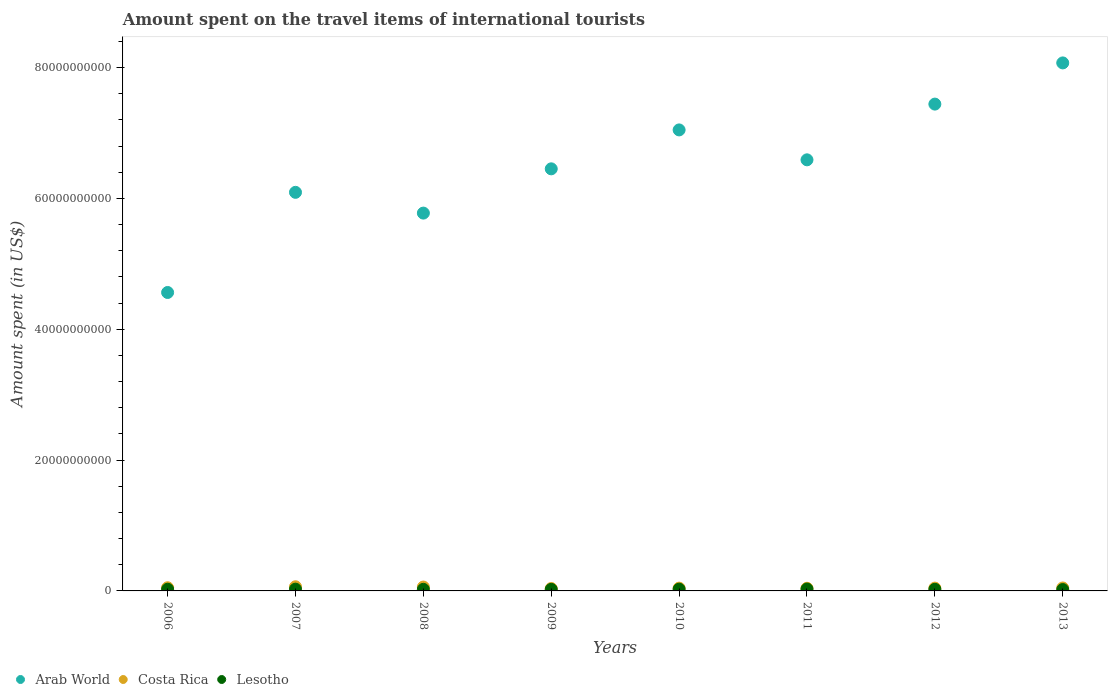Is the number of dotlines equal to the number of legend labels?
Your answer should be compact. Yes. What is the amount spent on the travel items of international tourists in Arab World in 2006?
Offer a very short reply. 4.56e+1. Across all years, what is the maximum amount spent on the travel items of international tourists in Costa Rica?
Provide a short and direct response. 6.34e+08. Across all years, what is the minimum amount spent on the travel items of international tourists in Costa Rica?
Keep it short and to the point. 3.67e+08. In which year was the amount spent on the travel items of international tourists in Lesotho minimum?
Ensure brevity in your answer.  2013. What is the total amount spent on the travel items of international tourists in Costa Rica in the graph?
Provide a short and direct response. 3.79e+09. What is the difference between the amount spent on the travel items of international tourists in Costa Rica in 2006 and that in 2011?
Provide a short and direct response. 8.00e+07. What is the difference between the amount spent on the travel items of international tourists in Arab World in 2009 and the amount spent on the travel items of international tourists in Lesotho in 2010?
Offer a terse response. 6.42e+1. What is the average amount spent on the travel items of international tourists in Lesotho per year?
Offer a very short reply. 2.54e+08. In the year 2007, what is the difference between the amount spent on the travel items of international tourists in Lesotho and amount spent on the travel items of international tourists in Costa Rica?
Offer a very short reply. -3.66e+08. What is the ratio of the amount spent on the travel items of international tourists in Lesotho in 2008 to that in 2009?
Provide a short and direct response. 1.02. Is the amount spent on the travel items of international tourists in Lesotho in 2009 less than that in 2011?
Make the answer very short. Yes. What is the difference between the highest and the second highest amount spent on the travel items of international tourists in Costa Rica?
Provide a succinct answer. 4.10e+07. What is the difference between the highest and the lowest amount spent on the travel items of international tourists in Arab World?
Offer a terse response. 3.51e+1. Is the sum of the amount spent on the travel items of international tourists in Lesotho in 2011 and 2012 greater than the maximum amount spent on the travel items of international tourists in Costa Rica across all years?
Your answer should be compact. No. Is it the case that in every year, the sum of the amount spent on the travel items of international tourists in Arab World and amount spent on the travel items of international tourists in Costa Rica  is greater than the amount spent on the travel items of international tourists in Lesotho?
Provide a succinct answer. Yes. Does the amount spent on the travel items of international tourists in Lesotho monotonically increase over the years?
Your response must be concise. No. How many legend labels are there?
Your response must be concise. 3. How are the legend labels stacked?
Provide a short and direct response. Horizontal. What is the title of the graph?
Provide a short and direct response. Amount spent on the travel items of international tourists. Does "Turkey" appear as one of the legend labels in the graph?
Provide a short and direct response. No. What is the label or title of the Y-axis?
Provide a short and direct response. Amount spent (in US$). What is the Amount spent (in US$) in Arab World in 2006?
Your answer should be compact. 4.56e+1. What is the Amount spent (in US$) of Costa Rica in 2006?
Your answer should be very brief. 4.85e+08. What is the Amount spent (in US$) in Lesotho in 2006?
Your response must be concise. 2.60e+08. What is the Amount spent (in US$) in Arab World in 2007?
Make the answer very short. 6.09e+1. What is the Amount spent (in US$) in Costa Rica in 2007?
Offer a terse response. 6.34e+08. What is the Amount spent (in US$) in Lesotho in 2007?
Offer a terse response. 2.68e+08. What is the Amount spent (in US$) of Arab World in 2008?
Your answer should be compact. 5.78e+1. What is the Amount spent (in US$) of Costa Rica in 2008?
Your response must be concise. 5.93e+08. What is the Amount spent (in US$) of Lesotho in 2008?
Offer a terse response. 2.43e+08. What is the Amount spent (in US$) of Arab World in 2009?
Make the answer very short. 6.45e+1. What is the Amount spent (in US$) of Costa Rica in 2009?
Offer a terse response. 3.67e+08. What is the Amount spent (in US$) of Lesotho in 2009?
Provide a short and direct response. 2.39e+08. What is the Amount spent (in US$) in Arab World in 2010?
Keep it short and to the point. 7.05e+1. What is the Amount spent (in US$) of Costa Rica in 2010?
Offer a very short reply. 4.24e+08. What is the Amount spent (in US$) in Lesotho in 2010?
Provide a succinct answer. 2.70e+08. What is the Amount spent (in US$) of Arab World in 2011?
Make the answer very short. 6.59e+1. What is the Amount spent (in US$) of Costa Rica in 2011?
Ensure brevity in your answer.  4.05e+08. What is the Amount spent (in US$) of Lesotho in 2011?
Keep it short and to the point. 2.90e+08. What is the Amount spent (in US$) in Arab World in 2012?
Keep it short and to the point. 7.44e+1. What is the Amount spent (in US$) in Costa Rica in 2012?
Keep it short and to the point. 4.29e+08. What is the Amount spent (in US$) in Lesotho in 2012?
Provide a short and direct response. 2.48e+08. What is the Amount spent (in US$) in Arab World in 2013?
Give a very brief answer. 8.07e+1. What is the Amount spent (in US$) of Costa Rica in 2013?
Your response must be concise. 4.50e+08. What is the Amount spent (in US$) in Lesotho in 2013?
Offer a terse response. 2.10e+08. Across all years, what is the maximum Amount spent (in US$) of Arab World?
Your response must be concise. 8.07e+1. Across all years, what is the maximum Amount spent (in US$) of Costa Rica?
Provide a succinct answer. 6.34e+08. Across all years, what is the maximum Amount spent (in US$) of Lesotho?
Your answer should be very brief. 2.90e+08. Across all years, what is the minimum Amount spent (in US$) of Arab World?
Make the answer very short. 4.56e+1. Across all years, what is the minimum Amount spent (in US$) in Costa Rica?
Offer a very short reply. 3.67e+08. Across all years, what is the minimum Amount spent (in US$) in Lesotho?
Offer a terse response. 2.10e+08. What is the total Amount spent (in US$) in Arab World in the graph?
Your answer should be compact. 5.20e+11. What is the total Amount spent (in US$) in Costa Rica in the graph?
Keep it short and to the point. 3.79e+09. What is the total Amount spent (in US$) of Lesotho in the graph?
Provide a succinct answer. 2.03e+09. What is the difference between the Amount spent (in US$) of Arab World in 2006 and that in 2007?
Provide a short and direct response. -1.53e+1. What is the difference between the Amount spent (in US$) in Costa Rica in 2006 and that in 2007?
Your response must be concise. -1.49e+08. What is the difference between the Amount spent (in US$) in Lesotho in 2006 and that in 2007?
Make the answer very short. -8.00e+06. What is the difference between the Amount spent (in US$) of Arab World in 2006 and that in 2008?
Provide a short and direct response. -1.21e+1. What is the difference between the Amount spent (in US$) of Costa Rica in 2006 and that in 2008?
Provide a short and direct response. -1.08e+08. What is the difference between the Amount spent (in US$) of Lesotho in 2006 and that in 2008?
Offer a terse response. 1.70e+07. What is the difference between the Amount spent (in US$) of Arab World in 2006 and that in 2009?
Your answer should be very brief. -1.89e+1. What is the difference between the Amount spent (in US$) of Costa Rica in 2006 and that in 2009?
Ensure brevity in your answer.  1.18e+08. What is the difference between the Amount spent (in US$) in Lesotho in 2006 and that in 2009?
Your answer should be compact. 2.10e+07. What is the difference between the Amount spent (in US$) of Arab World in 2006 and that in 2010?
Your response must be concise. -2.48e+1. What is the difference between the Amount spent (in US$) of Costa Rica in 2006 and that in 2010?
Provide a succinct answer. 6.10e+07. What is the difference between the Amount spent (in US$) in Lesotho in 2006 and that in 2010?
Ensure brevity in your answer.  -1.00e+07. What is the difference between the Amount spent (in US$) in Arab World in 2006 and that in 2011?
Keep it short and to the point. -2.03e+1. What is the difference between the Amount spent (in US$) of Costa Rica in 2006 and that in 2011?
Your response must be concise. 8.00e+07. What is the difference between the Amount spent (in US$) of Lesotho in 2006 and that in 2011?
Offer a very short reply. -3.00e+07. What is the difference between the Amount spent (in US$) in Arab World in 2006 and that in 2012?
Give a very brief answer. -2.88e+1. What is the difference between the Amount spent (in US$) in Costa Rica in 2006 and that in 2012?
Make the answer very short. 5.60e+07. What is the difference between the Amount spent (in US$) of Lesotho in 2006 and that in 2012?
Your answer should be compact. 1.20e+07. What is the difference between the Amount spent (in US$) in Arab World in 2006 and that in 2013?
Your response must be concise. -3.51e+1. What is the difference between the Amount spent (in US$) of Costa Rica in 2006 and that in 2013?
Your response must be concise. 3.50e+07. What is the difference between the Amount spent (in US$) of Arab World in 2007 and that in 2008?
Your answer should be very brief. 3.17e+09. What is the difference between the Amount spent (in US$) in Costa Rica in 2007 and that in 2008?
Provide a succinct answer. 4.10e+07. What is the difference between the Amount spent (in US$) of Lesotho in 2007 and that in 2008?
Your response must be concise. 2.50e+07. What is the difference between the Amount spent (in US$) of Arab World in 2007 and that in 2009?
Your answer should be very brief. -3.59e+09. What is the difference between the Amount spent (in US$) in Costa Rica in 2007 and that in 2009?
Your answer should be compact. 2.67e+08. What is the difference between the Amount spent (in US$) in Lesotho in 2007 and that in 2009?
Provide a short and direct response. 2.90e+07. What is the difference between the Amount spent (in US$) in Arab World in 2007 and that in 2010?
Provide a succinct answer. -9.54e+09. What is the difference between the Amount spent (in US$) in Costa Rica in 2007 and that in 2010?
Your answer should be compact. 2.10e+08. What is the difference between the Amount spent (in US$) in Arab World in 2007 and that in 2011?
Your response must be concise. -4.97e+09. What is the difference between the Amount spent (in US$) in Costa Rica in 2007 and that in 2011?
Keep it short and to the point. 2.29e+08. What is the difference between the Amount spent (in US$) of Lesotho in 2007 and that in 2011?
Give a very brief answer. -2.20e+07. What is the difference between the Amount spent (in US$) in Arab World in 2007 and that in 2012?
Your answer should be very brief. -1.35e+1. What is the difference between the Amount spent (in US$) in Costa Rica in 2007 and that in 2012?
Offer a very short reply. 2.05e+08. What is the difference between the Amount spent (in US$) of Lesotho in 2007 and that in 2012?
Offer a very short reply. 2.00e+07. What is the difference between the Amount spent (in US$) of Arab World in 2007 and that in 2013?
Provide a short and direct response. -1.98e+1. What is the difference between the Amount spent (in US$) in Costa Rica in 2007 and that in 2013?
Ensure brevity in your answer.  1.84e+08. What is the difference between the Amount spent (in US$) in Lesotho in 2007 and that in 2013?
Provide a succinct answer. 5.80e+07. What is the difference between the Amount spent (in US$) in Arab World in 2008 and that in 2009?
Make the answer very short. -6.77e+09. What is the difference between the Amount spent (in US$) of Costa Rica in 2008 and that in 2009?
Your response must be concise. 2.26e+08. What is the difference between the Amount spent (in US$) in Lesotho in 2008 and that in 2009?
Make the answer very short. 4.00e+06. What is the difference between the Amount spent (in US$) in Arab World in 2008 and that in 2010?
Your answer should be compact. -1.27e+1. What is the difference between the Amount spent (in US$) in Costa Rica in 2008 and that in 2010?
Provide a short and direct response. 1.69e+08. What is the difference between the Amount spent (in US$) in Lesotho in 2008 and that in 2010?
Your response must be concise. -2.70e+07. What is the difference between the Amount spent (in US$) of Arab World in 2008 and that in 2011?
Keep it short and to the point. -8.14e+09. What is the difference between the Amount spent (in US$) of Costa Rica in 2008 and that in 2011?
Make the answer very short. 1.88e+08. What is the difference between the Amount spent (in US$) in Lesotho in 2008 and that in 2011?
Provide a succinct answer. -4.70e+07. What is the difference between the Amount spent (in US$) in Arab World in 2008 and that in 2012?
Provide a short and direct response. -1.67e+1. What is the difference between the Amount spent (in US$) of Costa Rica in 2008 and that in 2012?
Offer a very short reply. 1.64e+08. What is the difference between the Amount spent (in US$) of Lesotho in 2008 and that in 2012?
Your response must be concise. -5.00e+06. What is the difference between the Amount spent (in US$) of Arab World in 2008 and that in 2013?
Offer a very short reply. -2.30e+1. What is the difference between the Amount spent (in US$) in Costa Rica in 2008 and that in 2013?
Give a very brief answer. 1.43e+08. What is the difference between the Amount spent (in US$) of Lesotho in 2008 and that in 2013?
Provide a short and direct response. 3.30e+07. What is the difference between the Amount spent (in US$) in Arab World in 2009 and that in 2010?
Offer a terse response. -5.95e+09. What is the difference between the Amount spent (in US$) of Costa Rica in 2009 and that in 2010?
Provide a short and direct response. -5.70e+07. What is the difference between the Amount spent (in US$) in Lesotho in 2009 and that in 2010?
Provide a succinct answer. -3.10e+07. What is the difference between the Amount spent (in US$) in Arab World in 2009 and that in 2011?
Provide a short and direct response. -1.38e+09. What is the difference between the Amount spent (in US$) of Costa Rica in 2009 and that in 2011?
Make the answer very short. -3.80e+07. What is the difference between the Amount spent (in US$) of Lesotho in 2009 and that in 2011?
Ensure brevity in your answer.  -5.10e+07. What is the difference between the Amount spent (in US$) in Arab World in 2009 and that in 2012?
Make the answer very short. -9.90e+09. What is the difference between the Amount spent (in US$) of Costa Rica in 2009 and that in 2012?
Keep it short and to the point. -6.20e+07. What is the difference between the Amount spent (in US$) in Lesotho in 2009 and that in 2012?
Your response must be concise. -9.00e+06. What is the difference between the Amount spent (in US$) of Arab World in 2009 and that in 2013?
Keep it short and to the point. -1.62e+1. What is the difference between the Amount spent (in US$) in Costa Rica in 2009 and that in 2013?
Your answer should be compact. -8.30e+07. What is the difference between the Amount spent (in US$) of Lesotho in 2009 and that in 2013?
Offer a terse response. 2.90e+07. What is the difference between the Amount spent (in US$) of Arab World in 2010 and that in 2011?
Make the answer very short. 4.57e+09. What is the difference between the Amount spent (in US$) of Costa Rica in 2010 and that in 2011?
Ensure brevity in your answer.  1.90e+07. What is the difference between the Amount spent (in US$) in Lesotho in 2010 and that in 2011?
Provide a succinct answer. -2.00e+07. What is the difference between the Amount spent (in US$) of Arab World in 2010 and that in 2012?
Your response must be concise. -3.95e+09. What is the difference between the Amount spent (in US$) of Costa Rica in 2010 and that in 2012?
Your response must be concise. -5.00e+06. What is the difference between the Amount spent (in US$) in Lesotho in 2010 and that in 2012?
Provide a succinct answer. 2.20e+07. What is the difference between the Amount spent (in US$) in Arab World in 2010 and that in 2013?
Provide a short and direct response. -1.02e+1. What is the difference between the Amount spent (in US$) of Costa Rica in 2010 and that in 2013?
Give a very brief answer. -2.60e+07. What is the difference between the Amount spent (in US$) in Lesotho in 2010 and that in 2013?
Offer a terse response. 6.00e+07. What is the difference between the Amount spent (in US$) of Arab World in 2011 and that in 2012?
Give a very brief answer. -8.52e+09. What is the difference between the Amount spent (in US$) in Costa Rica in 2011 and that in 2012?
Your response must be concise. -2.40e+07. What is the difference between the Amount spent (in US$) in Lesotho in 2011 and that in 2012?
Offer a very short reply. 4.20e+07. What is the difference between the Amount spent (in US$) in Arab World in 2011 and that in 2013?
Your answer should be compact. -1.48e+1. What is the difference between the Amount spent (in US$) of Costa Rica in 2011 and that in 2013?
Provide a short and direct response. -4.50e+07. What is the difference between the Amount spent (in US$) of Lesotho in 2011 and that in 2013?
Make the answer very short. 8.00e+07. What is the difference between the Amount spent (in US$) of Arab World in 2012 and that in 2013?
Offer a terse response. -6.30e+09. What is the difference between the Amount spent (in US$) in Costa Rica in 2012 and that in 2013?
Give a very brief answer. -2.10e+07. What is the difference between the Amount spent (in US$) of Lesotho in 2012 and that in 2013?
Your response must be concise. 3.80e+07. What is the difference between the Amount spent (in US$) of Arab World in 2006 and the Amount spent (in US$) of Costa Rica in 2007?
Ensure brevity in your answer.  4.50e+1. What is the difference between the Amount spent (in US$) in Arab World in 2006 and the Amount spent (in US$) in Lesotho in 2007?
Give a very brief answer. 4.54e+1. What is the difference between the Amount spent (in US$) in Costa Rica in 2006 and the Amount spent (in US$) in Lesotho in 2007?
Offer a very short reply. 2.17e+08. What is the difference between the Amount spent (in US$) of Arab World in 2006 and the Amount spent (in US$) of Costa Rica in 2008?
Provide a succinct answer. 4.50e+1. What is the difference between the Amount spent (in US$) in Arab World in 2006 and the Amount spent (in US$) in Lesotho in 2008?
Your answer should be very brief. 4.54e+1. What is the difference between the Amount spent (in US$) of Costa Rica in 2006 and the Amount spent (in US$) of Lesotho in 2008?
Keep it short and to the point. 2.42e+08. What is the difference between the Amount spent (in US$) in Arab World in 2006 and the Amount spent (in US$) in Costa Rica in 2009?
Provide a short and direct response. 4.53e+1. What is the difference between the Amount spent (in US$) of Arab World in 2006 and the Amount spent (in US$) of Lesotho in 2009?
Ensure brevity in your answer.  4.54e+1. What is the difference between the Amount spent (in US$) of Costa Rica in 2006 and the Amount spent (in US$) of Lesotho in 2009?
Provide a succinct answer. 2.46e+08. What is the difference between the Amount spent (in US$) in Arab World in 2006 and the Amount spent (in US$) in Costa Rica in 2010?
Your answer should be compact. 4.52e+1. What is the difference between the Amount spent (in US$) in Arab World in 2006 and the Amount spent (in US$) in Lesotho in 2010?
Your response must be concise. 4.53e+1. What is the difference between the Amount spent (in US$) in Costa Rica in 2006 and the Amount spent (in US$) in Lesotho in 2010?
Ensure brevity in your answer.  2.15e+08. What is the difference between the Amount spent (in US$) of Arab World in 2006 and the Amount spent (in US$) of Costa Rica in 2011?
Offer a terse response. 4.52e+1. What is the difference between the Amount spent (in US$) of Arab World in 2006 and the Amount spent (in US$) of Lesotho in 2011?
Keep it short and to the point. 4.53e+1. What is the difference between the Amount spent (in US$) of Costa Rica in 2006 and the Amount spent (in US$) of Lesotho in 2011?
Offer a terse response. 1.95e+08. What is the difference between the Amount spent (in US$) in Arab World in 2006 and the Amount spent (in US$) in Costa Rica in 2012?
Keep it short and to the point. 4.52e+1. What is the difference between the Amount spent (in US$) in Arab World in 2006 and the Amount spent (in US$) in Lesotho in 2012?
Keep it short and to the point. 4.54e+1. What is the difference between the Amount spent (in US$) of Costa Rica in 2006 and the Amount spent (in US$) of Lesotho in 2012?
Provide a short and direct response. 2.37e+08. What is the difference between the Amount spent (in US$) of Arab World in 2006 and the Amount spent (in US$) of Costa Rica in 2013?
Make the answer very short. 4.52e+1. What is the difference between the Amount spent (in US$) of Arab World in 2006 and the Amount spent (in US$) of Lesotho in 2013?
Make the answer very short. 4.54e+1. What is the difference between the Amount spent (in US$) of Costa Rica in 2006 and the Amount spent (in US$) of Lesotho in 2013?
Provide a succinct answer. 2.75e+08. What is the difference between the Amount spent (in US$) in Arab World in 2007 and the Amount spent (in US$) in Costa Rica in 2008?
Your answer should be very brief. 6.03e+1. What is the difference between the Amount spent (in US$) in Arab World in 2007 and the Amount spent (in US$) in Lesotho in 2008?
Give a very brief answer. 6.07e+1. What is the difference between the Amount spent (in US$) in Costa Rica in 2007 and the Amount spent (in US$) in Lesotho in 2008?
Offer a very short reply. 3.91e+08. What is the difference between the Amount spent (in US$) in Arab World in 2007 and the Amount spent (in US$) in Costa Rica in 2009?
Your answer should be compact. 6.06e+1. What is the difference between the Amount spent (in US$) of Arab World in 2007 and the Amount spent (in US$) of Lesotho in 2009?
Your response must be concise. 6.07e+1. What is the difference between the Amount spent (in US$) of Costa Rica in 2007 and the Amount spent (in US$) of Lesotho in 2009?
Offer a very short reply. 3.95e+08. What is the difference between the Amount spent (in US$) of Arab World in 2007 and the Amount spent (in US$) of Costa Rica in 2010?
Offer a terse response. 6.05e+1. What is the difference between the Amount spent (in US$) in Arab World in 2007 and the Amount spent (in US$) in Lesotho in 2010?
Your answer should be compact. 6.07e+1. What is the difference between the Amount spent (in US$) in Costa Rica in 2007 and the Amount spent (in US$) in Lesotho in 2010?
Your response must be concise. 3.64e+08. What is the difference between the Amount spent (in US$) of Arab World in 2007 and the Amount spent (in US$) of Costa Rica in 2011?
Make the answer very short. 6.05e+1. What is the difference between the Amount spent (in US$) of Arab World in 2007 and the Amount spent (in US$) of Lesotho in 2011?
Give a very brief answer. 6.06e+1. What is the difference between the Amount spent (in US$) in Costa Rica in 2007 and the Amount spent (in US$) in Lesotho in 2011?
Give a very brief answer. 3.44e+08. What is the difference between the Amount spent (in US$) of Arab World in 2007 and the Amount spent (in US$) of Costa Rica in 2012?
Your answer should be very brief. 6.05e+1. What is the difference between the Amount spent (in US$) of Arab World in 2007 and the Amount spent (in US$) of Lesotho in 2012?
Make the answer very short. 6.07e+1. What is the difference between the Amount spent (in US$) in Costa Rica in 2007 and the Amount spent (in US$) in Lesotho in 2012?
Provide a short and direct response. 3.86e+08. What is the difference between the Amount spent (in US$) of Arab World in 2007 and the Amount spent (in US$) of Costa Rica in 2013?
Provide a short and direct response. 6.05e+1. What is the difference between the Amount spent (in US$) of Arab World in 2007 and the Amount spent (in US$) of Lesotho in 2013?
Offer a very short reply. 6.07e+1. What is the difference between the Amount spent (in US$) of Costa Rica in 2007 and the Amount spent (in US$) of Lesotho in 2013?
Offer a very short reply. 4.24e+08. What is the difference between the Amount spent (in US$) of Arab World in 2008 and the Amount spent (in US$) of Costa Rica in 2009?
Your response must be concise. 5.74e+1. What is the difference between the Amount spent (in US$) in Arab World in 2008 and the Amount spent (in US$) in Lesotho in 2009?
Offer a very short reply. 5.75e+1. What is the difference between the Amount spent (in US$) of Costa Rica in 2008 and the Amount spent (in US$) of Lesotho in 2009?
Make the answer very short. 3.54e+08. What is the difference between the Amount spent (in US$) in Arab World in 2008 and the Amount spent (in US$) in Costa Rica in 2010?
Provide a short and direct response. 5.73e+1. What is the difference between the Amount spent (in US$) of Arab World in 2008 and the Amount spent (in US$) of Lesotho in 2010?
Make the answer very short. 5.75e+1. What is the difference between the Amount spent (in US$) in Costa Rica in 2008 and the Amount spent (in US$) in Lesotho in 2010?
Provide a short and direct response. 3.23e+08. What is the difference between the Amount spent (in US$) of Arab World in 2008 and the Amount spent (in US$) of Costa Rica in 2011?
Keep it short and to the point. 5.73e+1. What is the difference between the Amount spent (in US$) in Arab World in 2008 and the Amount spent (in US$) in Lesotho in 2011?
Your answer should be very brief. 5.75e+1. What is the difference between the Amount spent (in US$) in Costa Rica in 2008 and the Amount spent (in US$) in Lesotho in 2011?
Make the answer very short. 3.03e+08. What is the difference between the Amount spent (in US$) in Arab World in 2008 and the Amount spent (in US$) in Costa Rica in 2012?
Ensure brevity in your answer.  5.73e+1. What is the difference between the Amount spent (in US$) of Arab World in 2008 and the Amount spent (in US$) of Lesotho in 2012?
Offer a very short reply. 5.75e+1. What is the difference between the Amount spent (in US$) of Costa Rica in 2008 and the Amount spent (in US$) of Lesotho in 2012?
Your answer should be compact. 3.45e+08. What is the difference between the Amount spent (in US$) of Arab World in 2008 and the Amount spent (in US$) of Costa Rica in 2013?
Offer a terse response. 5.73e+1. What is the difference between the Amount spent (in US$) in Arab World in 2008 and the Amount spent (in US$) in Lesotho in 2013?
Give a very brief answer. 5.75e+1. What is the difference between the Amount spent (in US$) of Costa Rica in 2008 and the Amount spent (in US$) of Lesotho in 2013?
Provide a succinct answer. 3.83e+08. What is the difference between the Amount spent (in US$) in Arab World in 2009 and the Amount spent (in US$) in Costa Rica in 2010?
Make the answer very short. 6.41e+1. What is the difference between the Amount spent (in US$) of Arab World in 2009 and the Amount spent (in US$) of Lesotho in 2010?
Ensure brevity in your answer.  6.42e+1. What is the difference between the Amount spent (in US$) of Costa Rica in 2009 and the Amount spent (in US$) of Lesotho in 2010?
Your response must be concise. 9.70e+07. What is the difference between the Amount spent (in US$) of Arab World in 2009 and the Amount spent (in US$) of Costa Rica in 2011?
Ensure brevity in your answer.  6.41e+1. What is the difference between the Amount spent (in US$) in Arab World in 2009 and the Amount spent (in US$) in Lesotho in 2011?
Ensure brevity in your answer.  6.42e+1. What is the difference between the Amount spent (in US$) in Costa Rica in 2009 and the Amount spent (in US$) in Lesotho in 2011?
Provide a succinct answer. 7.70e+07. What is the difference between the Amount spent (in US$) in Arab World in 2009 and the Amount spent (in US$) in Costa Rica in 2012?
Your answer should be very brief. 6.41e+1. What is the difference between the Amount spent (in US$) of Arab World in 2009 and the Amount spent (in US$) of Lesotho in 2012?
Provide a succinct answer. 6.43e+1. What is the difference between the Amount spent (in US$) of Costa Rica in 2009 and the Amount spent (in US$) of Lesotho in 2012?
Offer a terse response. 1.19e+08. What is the difference between the Amount spent (in US$) in Arab World in 2009 and the Amount spent (in US$) in Costa Rica in 2013?
Your response must be concise. 6.41e+1. What is the difference between the Amount spent (in US$) in Arab World in 2009 and the Amount spent (in US$) in Lesotho in 2013?
Keep it short and to the point. 6.43e+1. What is the difference between the Amount spent (in US$) in Costa Rica in 2009 and the Amount spent (in US$) in Lesotho in 2013?
Give a very brief answer. 1.57e+08. What is the difference between the Amount spent (in US$) of Arab World in 2010 and the Amount spent (in US$) of Costa Rica in 2011?
Give a very brief answer. 7.01e+1. What is the difference between the Amount spent (in US$) of Arab World in 2010 and the Amount spent (in US$) of Lesotho in 2011?
Make the answer very short. 7.02e+1. What is the difference between the Amount spent (in US$) in Costa Rica in 2010 and the Amount spent (in US$) in Lesotho in 2011?
Make the answer very short. 1.34e+08. What is the difference between the Amount spent (in US$) of Arab World in 2010 and the Amount spent (in US$) of Costa Rica in 2012?
Your answer should be very brief. 7.00e+1. What is the difference between the Amount spent (in US$) in Arab World in 2010 and the Amount spent (in US$) in Lesotho in 2012?
Give a very brief answer. 7.02e+1. What is the difference between the Amount spent (in US$) of Costa Rica in 2010 and the Amount spent (in US$) of Lesotho in 2012?
Your answer should be very brief. 1.76e+08. What is the difference between the Amount spent (in US$) in Arab World in 2010 and the Amount spent (in US$) in Costa Rica in 2013?
Your response must be concise. 7.00e+1. What is the difference between the Amount spent (in US$) in Arab World in 2010 and the Amount spent (in US$) in Lesotho in 2013?
Your response must be concise. 7.03e+1. What is the difference between the Amount spent (in US$) in Costa Rica in 2010 and the Amount spent (in US$) in Lesotho in 2013?
Provide a succinct answer. 2.14e+08. What is the difference between the Amount spent (in US$) in Arab World in 2011 and the Amount spent (in US$) in Costa Rica in 2012?
Your answer should be compact. 6.55e+1. What is the difference between the Amount spent (in US$) of Arab World in 2011 and the Amount spent (in US$) of Lesotho in 2012?
Ensure brevity in your answer.  6.56e+1. What is the difference between the Amount spent (in US$) in Costa Rica in 2011 and the Amount spent (in US$) in Lesotho in 2012?
Ensure brevity in your answer.  1.57e+08. What is the difference between the Amount spent (in US$) in Arab World in 2011 and the Amount spent (in US$) in Costa Rica in 2013?
Keep it short and to the point. 6.54e+1. What is the difference between the Amount spent (in US$) in Arab World in 2011 and the Amount spent (in US$) in Lesotho in 2013?
Keep it short and to the point. 6.57e+1. What is the difference between the Amount spent (in US$) of Costa Rica in 2011 and the Amount spent (in US$) of Lesotho in 2013?
Keep it short and to the point. 1.95e+08. What is the difference between the Amount spent (in US$) of Arab World in 2012 and the Amount spent (in US$) of Costa Rica in 2013?
Offer a terse response. 7.40e+1. What is the difference between the Amount spent (in US$) of Arab World in 2012 and the Amount spent (in US$) of Lesotho in 2013?
Your response must be concise. 7.42e+1. What is the difference between the Amount spent (in US$) of Costa Rica in 2012 and the Amount spent (in US$) of Lesotho in 2013?
Keep it short and to the point. 2.19e+08. What is the average Amount spent (in US$) in Arab World per year?
Ensure brevity in your answer.  6.50e+1. What is the average Amount spent (in US$) in Costa Rica per year?
Your answer should be compact. 4.73e+08. What is the average Amount spent (in US$) of Lesotho per year?
Make the answer very short. 2.54e+08. In the year 2006, what is the difference between the Amount spent (in US$) in Arab World and Amount spent (in US$) in Costa Rica?
Your response must be concise. 4.51e+1. In the year 2006, what is the difference between the Amount spent (in US$) in Arab World and Amount spent (in US$) in Lesotho?
Provide a short and direct response. 4.54e+1. In the year 2006, what is the difference between the Amount spent (in US$) in Costa Rica and Amount spent (in US$) in Lesotho?
Give a very brief answer. 2.25e+08. In the year 2007, what is the difference between the Amount spent (in US$) in Arab World and Amount spent (in US$) in Costa Rica?
Provide a succinct answer. 6.03e+1. In the year 2007, what is the difference between the Amount spent (in US$) in Arab World and Amount spent (in US$) in Lesotho?
Provide a short and direct response. 6.07e+1. In the year 2007, what is the difference between the Amount spent (in US$) of Costa Rica and Amount spent (in US$) of Lesotho?
Your answer should be very brief. 3.66e+08. In the year 2008, what is the difference between the Amount spent (in US$) in Arab World and Amount spent (in US$) in Costa Rica?
Ensure brevity in your answer.  5.72e+1. In the year 2008, what is the difference between the Amount spent (in US$) in Arab World and Amount spent (in US$) in Lesotho?
Provide a short and direct response. 5.75e+1. In the year 2008, what is the difference between the Amount spent (in US$) of Costa Rica and Amount spent (in US$) of Lesotho?
Your answer should be very brief. 3.50e+08. In the year 2009, what is the difference between the Amount spent (in US$) of Arab World and Amount spent (in US$) of Costa Rica?
Keep it short and to the point. 6.42e+1. In the year 2009, what is the difference between the Amount spent (in US$) in Arab World and Amount spent (in US$) in Lesotho?
Your answer should be very brief. 6.43e+1. In the year 2009, what is the difference between the Amount spent (in US$) in Costa Rica and Amount spent (in US$) in Lesotho?
Your response must be concise. 1.28e+08. In the year 2010, what is the difference between the Amount spent (in US$) of Arab World and Amount spent (in US$) of Costa Rica?
Provide a short and direct response. 7.00e+1. In the year 2010, what is the difference between the Amount spent (in US$) of Arab World and Amount spent (in US$) of Lesotho?
Make the answer very short. 7.02e+1. In the year 2010, what is the difference between the Amount spent (in US$) in Costa Rica and Amount spent (in US$) in Lesotho?
Make the answer very short. 1.54e+08. In the year 2011, what is the difference between the Amount spent (in US$) of Arab World and Amount spent (in US$) of Costa Rica?
Make the answer very short. 6.55e+1. In the year 2011, what is the difference between the Amount spent (in US$) in Arab World and Amount spent (in US$) in Lesotho?
Offer a very short reply. 6.56e+1. In the year 2011, what is the difference between the Amount spent (in US$) in Costa Rica and Amount spent (in US$) in Lesotho?
Make the answer very short. 1.15e+08. In the year 2012, what is the difference between the Amount spent (in US$) in Arab World and Amount spent (in US$) in Costa Rica?
Your response must be concise. 7.40e+1. In the year 2012, what is the difference between the Amount spent (in US$) in Arab World and Amount spent (in US$) in Lesotho?
Provide a succinct answer. 7.42e+1. In the year 2012, what is the difference between the Amount spent (in US$) of Costa Rica and Amount spent (in US$) of Lesotho?
Your response must be concise. 1.81e+08. In the year 2013, what is the difference between the Amount spent (in US$) in Arab World and Amount spent (in US$) in Costa Rica?
Your answer should be compact. 8.03e+1. In the year 2013, what is the difference between the Amount spent (in US$) of Arab World and Amount spent (in US$) of Lesotho?
Your response must be concise. 8.05e+1. In the year 2013, what is the difference between the Amount spent (in US$) of Costa Rica and Amount spent (in US$) of Lesotho?
Your answer should be compact. 2.40e+08. What is the ratio of the Amount spent (in US$) of Arab World in 2006 to that in 2007?
Offer a very short reply. 0.75. What is the ratio of the Amount spent (in US$) in Costa Rica in 2006 to that in 2007?
Ensure brevity in your answer.  0.77. What is the ratio of the Amount spent (in US$) in Lesotho in 2006 to that in 2007?
Give a very brief answer. 0.97. What is the ratio of the Amount spent (in US$) of Arab World in 2006 to that in 2008?
Give a very brief answer. 0.79. What is the ratio of the Amount spent (in US$) in Costa Rica in 2006 to that in 2008?
Ensure brevity in your answer.  0.82. What is the ratio of the Amount spent (in US$) in Lesotho in 2006 to that in 2008?
Make the answer very short. 1.07. What is the ratio of the Amount spent (in US$) of Arab World in 2006 to that in 2009?
Ensure brevity in your answer.  0.71. What is the ratio of the Amount spent (in US$) in Costa Rica in 2006 to that in 2009?
Give a very brief answer. 1.32. What is the ratio of the Amount spent (in US$) of Lesotho in 2006 to that in 2009?
Offer a terse response. 1.09. What is the ratio of the Amount spent (in US$) of Arab World in 2006 to that in 2010?
Provide a short and direct response. 0.65. What is the ratio of the Amount spent (in US$) of Costa Rica in 2006 to that in 2010?
Your answer should be compact. 1.14. What is the ratio of the Amount spent (in US$) of Lesotho in 2006 to that in 2010?
Provide a succinct answer. 0.96. What is the ratio of the Amount spent (in US$) in Arab World in 2006 to that in 2011?
Provide a short and direct response. 0.69. What is the ratio of the Amount spent (in US$) in Costa Rica in 2006 to that in 2011?
Provide a succinct answer. 1.2. What is the ratio of the Amount spent (in US$) in Lesotho in 2006 to that in 2011?
Your answer should be very brief. 0.9. What is the ratio of the Amount spent (in US$) of Arab World in 2006 to that in 2012?
Keep it short and to the point. 0.61. What is the ratio of the Amount spent (in US$) of Costa Rica in 2006 to that in 2012?
Your response must be concise. 1.13. What is the ratio of the Amount spent (in US$) in Lesotho in 2006 to that in 2012?
Offer a very short reply. 1.05. What is the ratio of the Amount spent (in US$) in Arab World in 2006 to that in 2013?
Give a very brief answer. 0.57. What is the ratio of the Amount spent (in US$) of Costa Rica in 2006 to that in 2013?
Offer a very short reply. 1.08. What is the ratio of the Amount spent (in US$) of Lesotho in 2006 to that in 2013?
Make the answer very short. 1.24. What is the ratio of the Amount spent (in US$) in Arab World in 2007 to that in 2008?
Offer a very short reply. 1.05. What is the ratio of the Amount spent (in US$) of Costa Rica in 2007 to that in 2008?
Give a very brief answer. 1.07. What is the ratio of the Amount spent (in US$) of Lesotho in 2007 to that in 2008?
Your answer should be very brief. 1.1. What is the ratio of the Amount spent (in US$) in Arab World in 2007 to that in 2009?
Make the answer very short. 0.94. What is the ratio of the Amount spent (in US$) in Costa Rica in 2007 to that in 2009?
Offer a very short reply. 1.73. What is the ratio of the Amount spent (in US$) in Lesotho in 2007 to that in 2009?
Make the answer very short. 1.12. What is the ratio of the Amount spent (in US$) in Arab World in 2007 to that in 2010?
Your answer should be very brief. 0.86. What is the ratio of the Amount spent (in US$) in Costa Rica in 2007 to that in 2010?
Provide a short and direct response. 1.5. What is the ratio of the Amount spent (in US$) of Arab World in 2007 to that in 2011?
Offer a very short reply. 0.92. What is the ratio of the Amount spent (in US$) of Costa Rica in 2007 to that in 2011?
Provide a succinct answer. 1.57. What is the ratio of the Amount spent (in US$) of Lesotho in 2007 to that in 2011?
Your answer should be very brief. 0.92. What is the ratio of the Amount spent (in US$) in Arab World in 2007 to that in 2012?
Keep it short and to the point. 0.82. What is the ratio of the Amount spent (in US$) of Costa Rica in 2007 to that in 2012?
Your answer should be very brief. 1.48. What is the ratio of the Amount spent (in US$) of Lesotho in 2007 to that in 2012?
Give a very brief answer. 1.08. What is the ratio of the Amount spent (in US$) in Arab World in 2007 to that in 2013?
Your answer should be compact. 0.75. What is the ratio of the Amount spent (in US$) in Costa Rica in 2007 to that in 2013?
Ensure brevity in your answer.  1.41. What is the ratio of the Amount spent (in US$) of Lesotho in 2007 to that in 2013?
Give a very brief answer. 1.28. What is the ratio of the Amount spent (in US$) of Arab World in 2008 to that in 2009?
Make the answer very short. 0.9. What is the ratio of the Amount spent (in US$) in Costa Rica in 2008 to that in 2009?
Your answer should be very brief. 1.62. What is the ratio of the Amount spent (in US$) in Lesotho in 2008 to that in 2009?
Your answer should be very brief. 1.02. What is the ratio of the Amount spent (in US$) of Arab World in 2008 to that in 2010?
Provide a short and direct response. 0.82. What is the ratio of the Amount spent (in US$) in Costa Rica in 2008 to that in 2010?
Make the answer very short. 1.4. What is the ratio of the Amount spent (in US$) in Lesotho in 2008 to that in 2010?
Your response must be concise. 0.9. What is the ratio of the Amount spent (in US$) in Arab World in 2008 to that in 2011?
Give a very brief answer. 0.88. What is the ratio of the Amount spent (in US$) of Costa Rica in 2008 to that in 2011?
Give a very brief answer. 1.46. What is the ratio of the Amount spent (in US$) in Lesotho in 2008 to that in 2011?
Offer a very short reply. 0.84. What is the ratio of the Amount spent (in US$) in Arab World in 2008 to that in 2012?
Provide a succinct answer. 0.78. What is the ratio of the Amount spent (in US$) of Costa Rica in 2008 to that in 2012?
Provide a succinct answer. 1.38. What is the ratio of the Amount spent (in US$) in Lesotho in 2008 to that in 2012?
Make the answer very short. 0.98. What is the ratio of the Amount spent (in US$) of Arab World in 2008 to that in 2013?
Your answer should be compact. 0.72. What is the ratio of the Amount spent (in US$) in Costa Rica in 2008 to that in 2013?
Offer a terse response. 1.32. What is the ratio of the Amount spent (in US$) in Lesotho in 2008 to that in 2013?
Provide a short and direct response. 1.16. What is the ratio of the Amount spent (in US$) of Arab World in 2009 to that in 2010?
Offer a terse response. 0.92. What is the ratio of the Amount spent (in US$) in Costa Rica in 2009 to that in 2010?
Give a very brief answer. 0.87. What is the ratio of the Amount spent (in US$) in Lesotho in 2009 to that in 2010?
Your answer should be compact. 0.89. What is the ratio of the Amount spent (in US$) of Arab World in 2009 to that in 2011?
Provide a succinct answer. 0.98. What is the ratio of the Amount spent (in US$) in Costa Rica in 2009 to that in 2011?
Keep it short and to the point. 0.91. What is the ratio of the Amount spent (in US$) of Lesotho in 2009 to that in 2011?
Ensure brevity in your answer.  0.82. What is the ratio of the Amount spent (in US$) of Arab World in 2009 to that in 2012?
Keep it short and to the point. 0.87. What is the ratio of the Amount spent (in US$) of Costa Rica in 2009 to that in 2012?
Your answer should be very brief. 0.86. What is the ratio of the Amount spent (in US$) of Lesotho in 2009 to that in 2012?
Provide a succinct answer. 0.96. What is the ratio of the Amount spent (in US$) in Arab World in 2009 to that in 2013?
Your answer should be very brief. 0.8. What is the ratio of the Amount spent (in US$) in Costa Rica in 2009 to that in 2013?
Provide a succinct answer. 0.82. What is the ratio of the Amount spent (in US$) of Lesotho in 2009 to that in 2013?
Ensure brevity in your answer.  1.14. What is the ratio of the Amount spent (in US$) in Arab World in 2010 to that in 2011?
Provide a succinct answer. 1.07. What is the ratio of the Amount spent (in US$) in Costa Rica in 2010 to that in 2011?
Offer a terse response. 1.05. What is the ratio of the Amount spent (in US$) in Arab World in 2010 to that in 2012?
Offer a very short reply. 0.95. What is the ratio of the Amount spent (in US$) of Costa Rica in 2010 to that in 2012?
Your answer should be very brief. 0.99. What is the ratio of the Amount spent (in US$) of Lesotho in 2010 to that in 2012?
Give a very brief answer. 1.09. What is the ratio of the Amount spent (in US$) in Arab World in 2010 to that in 2013?
Provide a succinct answer. 0.87. What is the ratio of the Amount spent (in US$) in Costa Rica in 2010 to that in 2013?
Your response must be concise. 0.94. What is the ratio of the Amount spent (in US$) in Lesotho in 2010 to that in 2013?
Your answer should be very brief. 1.29. What is the ratio of the Amount spent (in US$) in Arab World in 2011 to that in 2012?
Provide a succinct answer. 0.89. What is the ratio of the Amount spent (in US$) in Costa Rica in 2011 to that in 2012?
Ensure brevity in your answer.  0.94. What is the ratio of the Amount spent (in US$) in Lesotho in 2011 to that in 2012?
Keep it short and to the point. 1.17. What is the ratio of the Amount spent (in US$) in Arab World in 2011 to that in 2013?
Offer a very short reply. 0.82. What is the ratio of the Amount spent (in US$) in Costa Rica in 2011 to that in 2013?
Make the answer very short. 0.9. What is the ratio of the Amount spent (in US$) in Lesotho in 2011 to that in 2013?
Your answer should be very brief. 1.38. What is the ratio of the Amount spent (in US$) in Arab World in 2012 to that in 2013?
Your response must be concise. 0.92. What is the ratio of the Amount spent (in US$) in Costa Rica in 2012 to that in 2013?
Provide a short and direct response. 0.95. What is the ratio of the Amount spent (in US$) in Lesotho in 2012 to that in 2013?
Give a very brief answer. 1.18. What is the difference between the highest and the second highest Amount spent (in US$) in Arab World?
Provide a succinct answer. 6.30e+09. What is the difference between the highest and the second highest Amount spent (in US$) of Costa Rica?
Your response must be concise. 4.10e+07. What is the difference between the highest and the lowest Amount spent (in US$) in Arab World?
Make the answer very short. 3.51e+1. What is the difference between the highest and the lowest Amount spent (in US$) in Costa Rica?
Keep it short and to the point. 2.67e+08. What is the difference between the highest and the lowest Amount spent (in US$) in Lesotho?
Keep it short and to the point. 8.00e+07. 